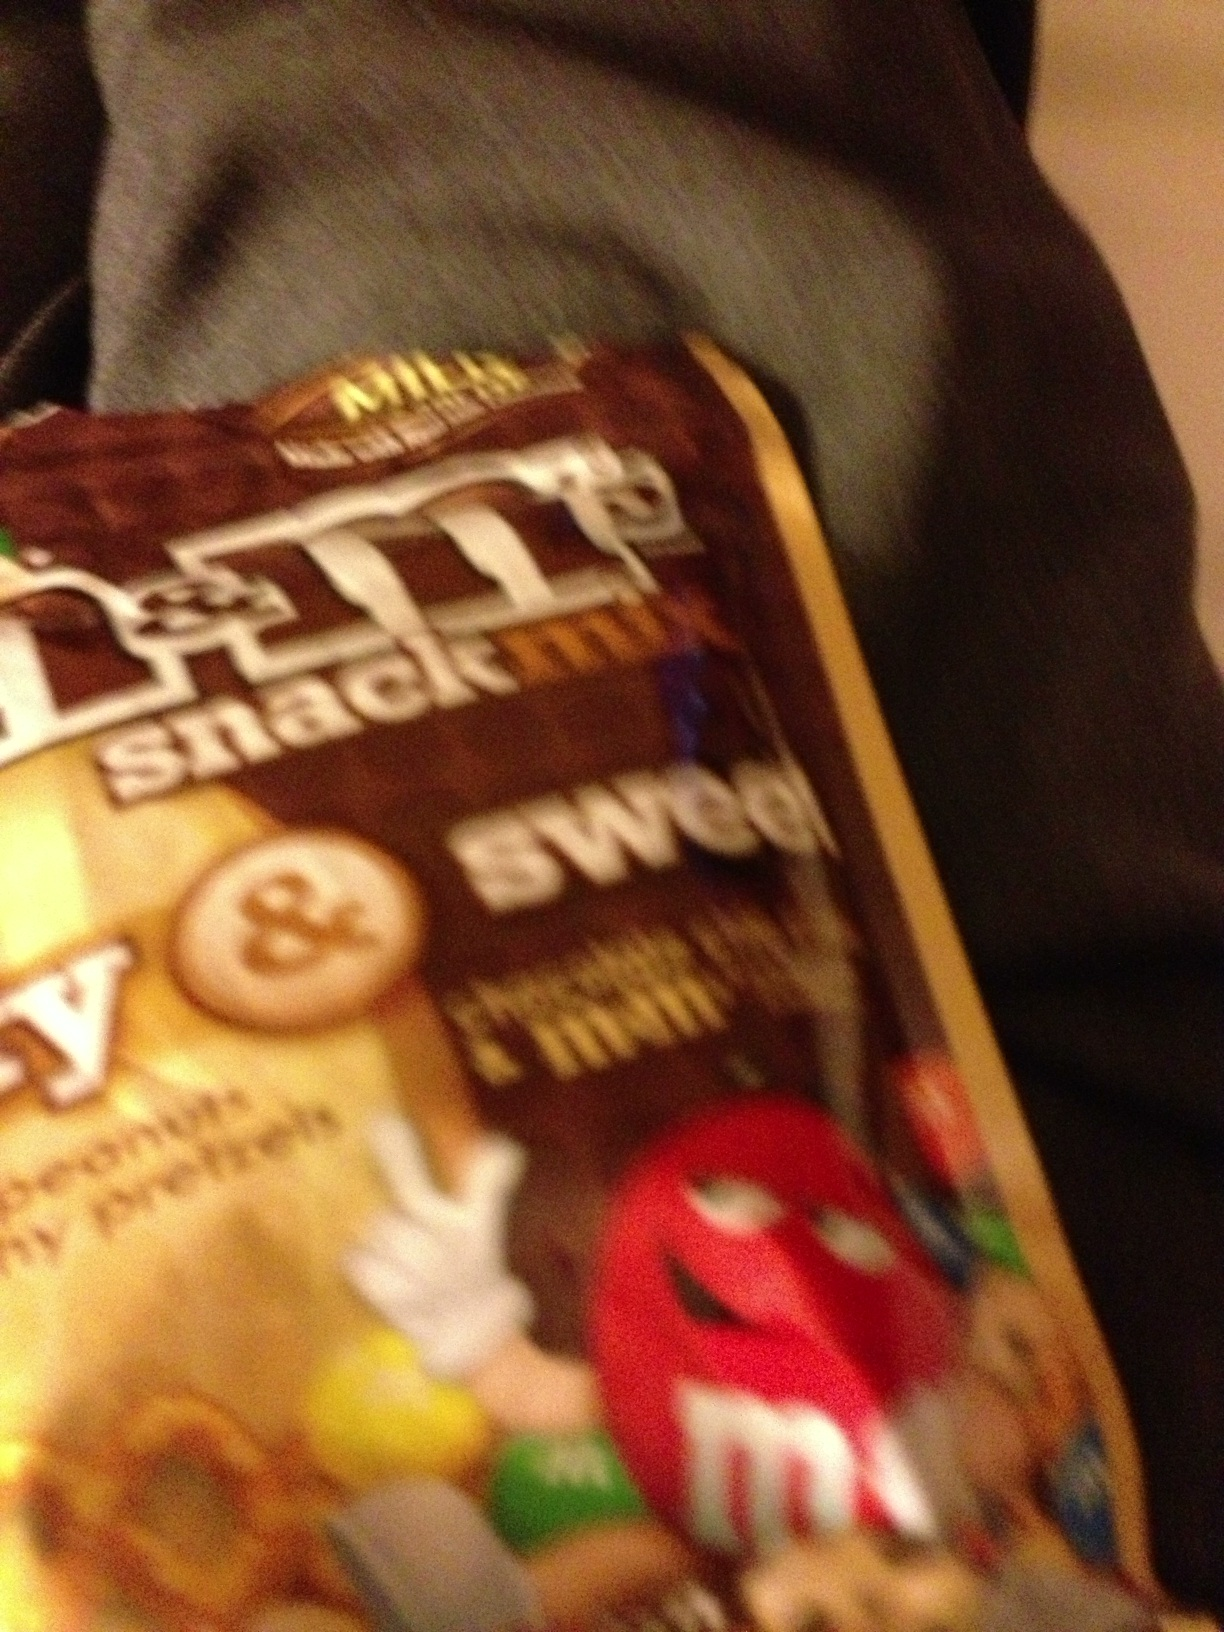How is the nutritional value of such a snack mix, especially considering health? M&Ms snack mix, like any similar product, contains a combination of sugar, salt, and fats. It's enjoyable for a treat, but moderation is key due to its high caloric content and sugar levels. It's generally not recommended for regular consumption if one is managing dietary restrictions related to health concerns like diabetes or heart disease. 